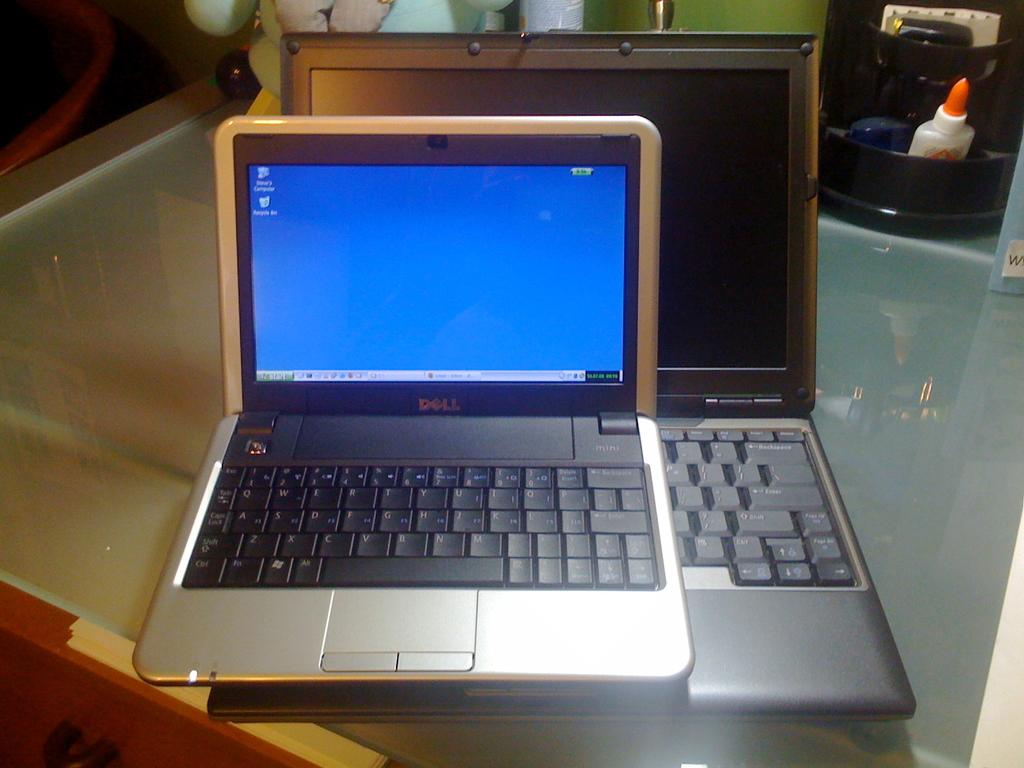What brand of computer is this?
Provide a short and direct response. Dell. What do the words under the icons on the front desktop say?
Ensure brevity in your answer.  Dell. 